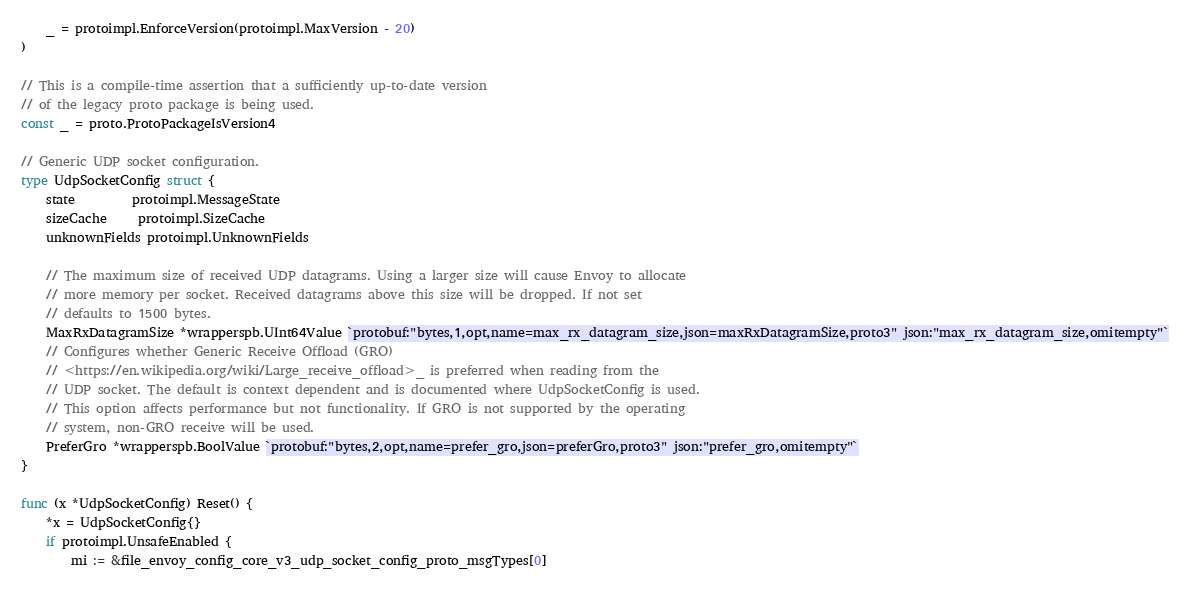<code> <loc_0><loc_0><loc_500><loc_500><_Go_>	_ = protoimpl.EnforceVersion(protoimpl.MaxVersion - 20)
)

// This is a compile-time assertion that a sufficiently up-to-date version
// of the legacy proto package is being used.
const _ = proto.ProtoPackageIsVersion4

// Generic UDP socket configuration.
type UdpSocketConfig struct {
	state         protoimpl.MessageState
	sizeCache     protoimpl.SizeCache
	unknownFields protoimpl.UnknownFields

	// The maximum size of received UDP datagrams. Using a larger size will cause Envoy to allocate
	// more memory per socket. Received datagrams above this size will be dropped. If not set
	// defaults to 1500 bytes.
	MaxRxDatagramSize *wrapperspb.UInt64Value `protobuf:"bytes,1,opt,name=max_rx_datagram_size,json=maxRxDatagramSize,proto3" json:"max_rx_datagram_size,omitempty"`
	// Configures whether Generic Receive Offload (GRO)
	// <https://en.wikipedia.org/wiki/Large_receive_offload>_ is preferred when reading from the
	// UDP socket. The default is context dependent and is documented where UdpSocketConfig is used.
	// This option affects performance but not functionality. If GRO is not supported by the operating
	// system, non-GRO receive will be used.
	PreferGro *wrapperspb.BoolValue `protobuf:"bytes,2,opt,name=prefer_gro,json=preferGro,proto3" json:"prefer_gro,omitempty"`
}

func (x *UdpSocketConfig) Reset() {
	*x = UdpSocketConfig{}
	if protoimpl.UnsafeEnabled {
		mi := &file_envoy_config_core_v3_udp_socket_config_proto_msgTypes[0]</code> 